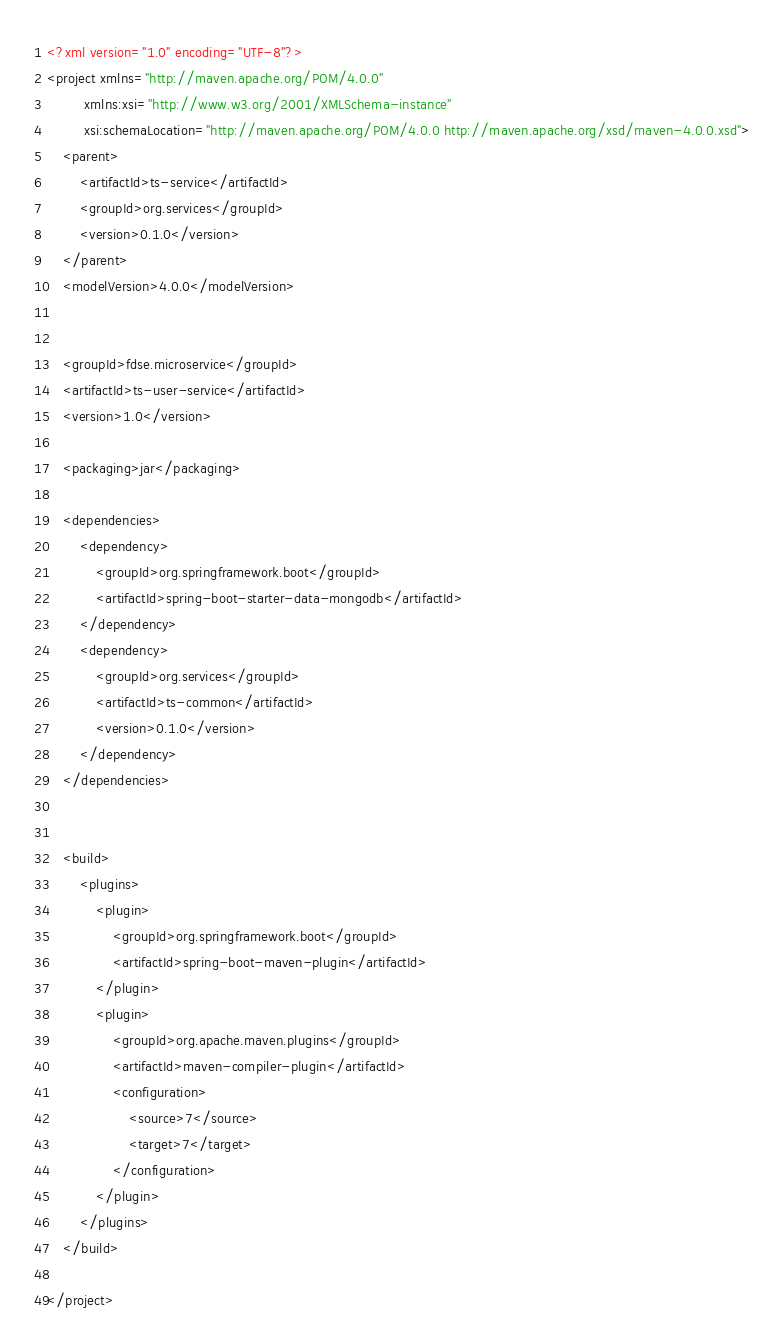<code> <loc_0><loc_0><loc_500><loc_500><_XML_><?xml version="1.0" encoding="UTF-8"?>
<project xmlns="http://maven.apache.org/POM/4.0.0"
         xmlns:xsi="http://www.w3.org/2001/XMLSchema-instance"
         xsi:schemaLocation="http://maven.apache.org/POM/4.0.0 http://maven.apache.org/xsd/maven-4.0.0.xsd">
    <parent>
        <artifactId>ts-service</artifactId>
        <groupId>org.services</groupId>
        <version>0.1.0</version>
    </parent>
    <modelVersion>4.0.0</modelVersion>


    <groupId>fdse.microservice</groupId>
    <artifactId>ts-user-service</artifactId>
    <version>1.0</version>

    <packaging>jar</packaging>

    <dependencies>
        <dependency>
            <groupId>org.springframework.boot</groupId>
            <artifactId>spring-boot-starter-data-mongodb</artifactId>
        </dependency>
        <dependency>
            <groupId>org.services</groupId>
            <artifactId>ts-common</artifactId>
            <version>0.1.0</version>
        </dependency>
    </dependencies>


    <build>
        <plugins>
            <plugin>
                <groupId>org.springframework.boot</groupId>
                <artifactId>spring-boot-maven-plugin</artifactId>
            </plugin>
            <plugin>
                <groupId>org.apache.maven.plugins</groupId>
                <artifactId>maven-compiler-plugin</artifactId>
                <configuration>
                    <source>7</source>
                    <target>7</target>
                </configuration>
            </plugin>
        </plugins>
    </build>

</project></code> 